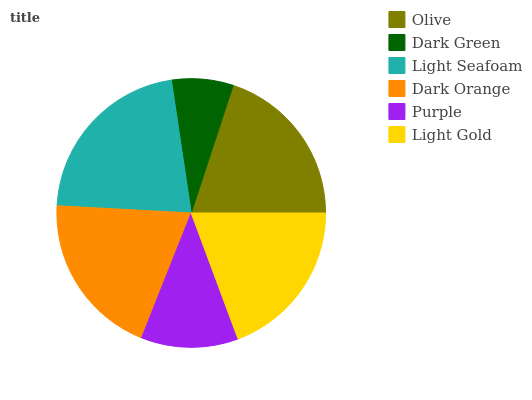Is Dark Green the minimum?
Answer yes or no. Yes. Is Light Seafoam the maximum?
Answer yes or no. Yes. Is Light Seafoam the minimum?
Answer yes or no. No. Is Dark Green the maximum?
Answer yes or no. No. Is Light Seafoam greater than Dark Green?
Answer yes or no. Yes. Is Dark Green less than Light Seafoam?
Answer yes or no. Yes. Is Dark Green greater than Light Seafoam?
Answer yes or no. No. Is Light Seafoam less than Dark Green?
Answer yes or no. No. Is Dark Orange the high median?
Answer yes or no. Yes. Is Light Gold the low median?
Answer yes or no. Yes. Is Light Seafoam the high median?
Answer yes or no. No. Is Olive the low median?
Answer yes or no. No. 